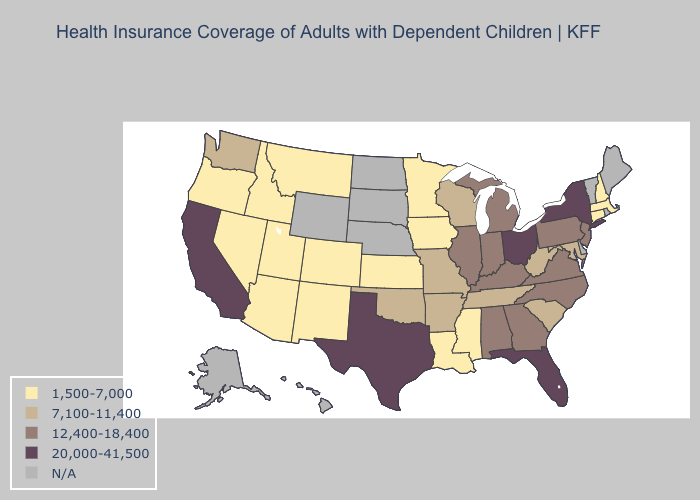What is the lowest value in the USA?
Concise answer only. 1,500-7,000. Does Arizona have the lowest value in the USA?
Short answer required. Yes. Name the states that have a value in the range 1,500-7,000?
Answer briefly. Arizona, Colorado, Connecticut, Idaho, Iowa, Kansas, Louisiana, Massachusetts, Minnesota, Mississippi, Montana, Nevada, New Hampshire, New Mexico, Oregon, Utah. What is the value of North Dakota?
Answer briefly. N/A. What is the lowest value in the USA?
Quick response, please. 1,500-7,000. What is the value of Virginia?
Concise answer only. 12,400-18,400. Name the states that have a value in the range N/A?
Give a very brief answer. Alaska, Delaware, Hawaii, Maine, Nebraska, North Dakota, Rhode Island, South Dakota, Vermont, Wyoming. Does Louisiana have the lowest value in the South?
Write a very short answer. Yes. Does Ohio have the highest value in the USA?
Write a very short answer. Yes. Does the first symbol in the legend represent the smallest category?
Be succinct. Yes. Does the first symbol in the legend represent the smallest category?
Short answer required. Yes. What is the highest value in the South ?
Keep it brief. 20,000-41,500. 